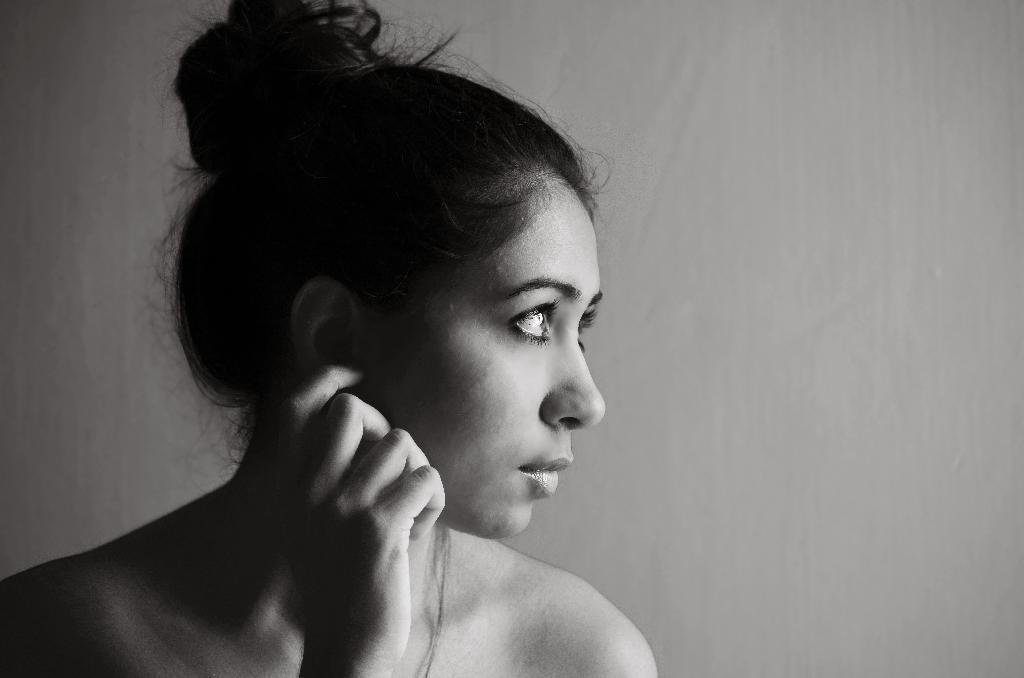What is the main subject of the image? There is a person in the image. What can be seen in the background of the image? There is a wall in the background of the image. What type of detail can be seen in the water during the summer season in the image? There is no water or summer season mentioned in the image, so it is not possible to answer that question. 